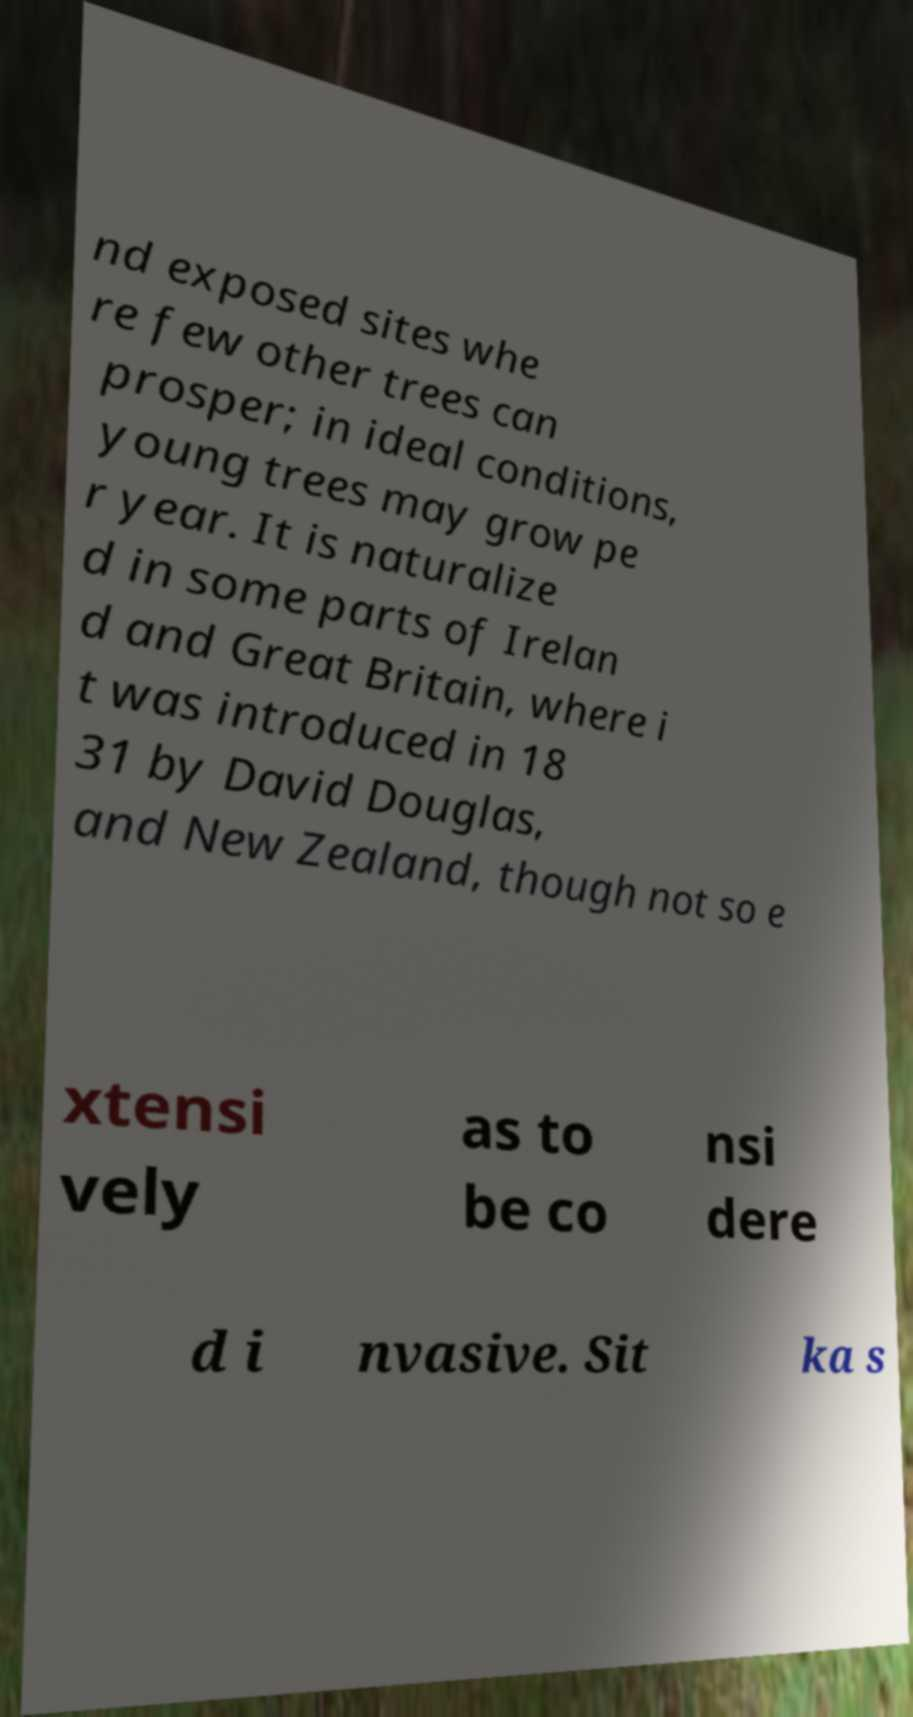What messages or text are displayed in this image? I need them in a readable, typed format. nd exposed sites whe re few other trees can prosper; in ideal conditions, young trees may grow pe r year. It is naturalize d in some parts of Irelan d and Great Britain, where i t was introduced in 18 31 by David Douglas, and New Zealand, though not so e xtensi vely as to be co nsi dere d i nvasive. Sit ka s 